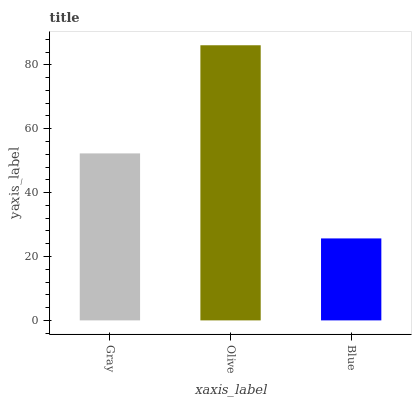Is Blue the minimum?
Answer yes or no. Yes. Is Olive the maximum?
Answer yes or no. Yes. Is Olive the minimum?
Answer yes or no. No. Is Blue the maximum?
Answer yes or no. No. Is Olive greater than Blue?
Answer yes or no. Yes. Is Blue less than Olive?
Answer yes or no. Yes. Is Blue greater than Olive?
Answer yes or no. No. Is Olive less than Blue?
Answer yes or no. No. Is Gray the high median?
Answer yes or no. Yes. Is Gray the low median?
Answer yes or no. Yes. Is Blue the high median?
Answer yes or no. No. Is Blue the low median?
Answer yes or no. No. 